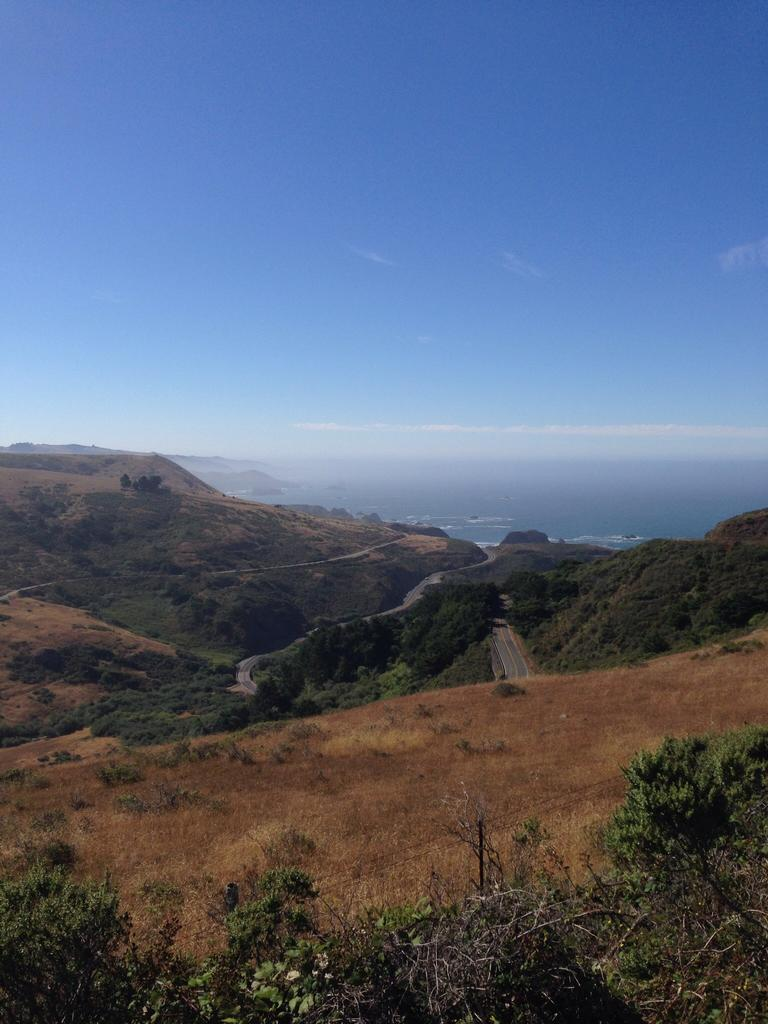Where was the image taken from? The image is taken from the outside. What type of natural elements can be seen in the image? There are trees in the image. What type of man-made structure is visible in the image? There is a road in the image. What part of the natural environment is visible in the image? The sky is visible in the image. What is the chance of winning the camp in the image? There is no camp present in the image, so it is not possible to determine the chance of winning anything related to a camp. 